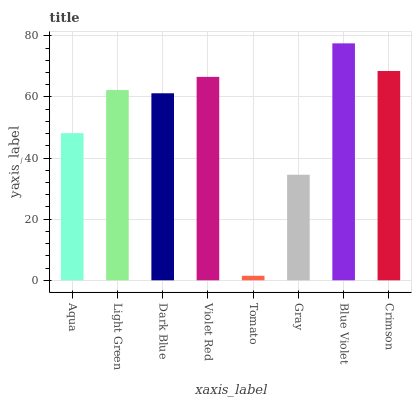Is Tomato the minimum?
Answer yes or no. Yes. Is Blue Violet the maximum?
Answer yes or no. Yes. Is Light Green the minimum?
Answer yes or no. No. Is Light Green the maximum?
Answer yes or no. No. Is Light Green greater than Aqua?
Answer yes or no. Yes. Is Aqua less than Light Green?
Answer yes or no. Yes. Is Aqua greater than Light Green?
Answer yes or no. No. Is Light Green less than Aqua?
Answer yes or no. No. Is Light Green the high median?
Answer yes or no. Yes. Is Dark Blue the low median?
Answer yes or no. Yes. Is Aqua the high median?
Answer yes or no. No. Is Tomato the low median?
Answer yes or no. No. 